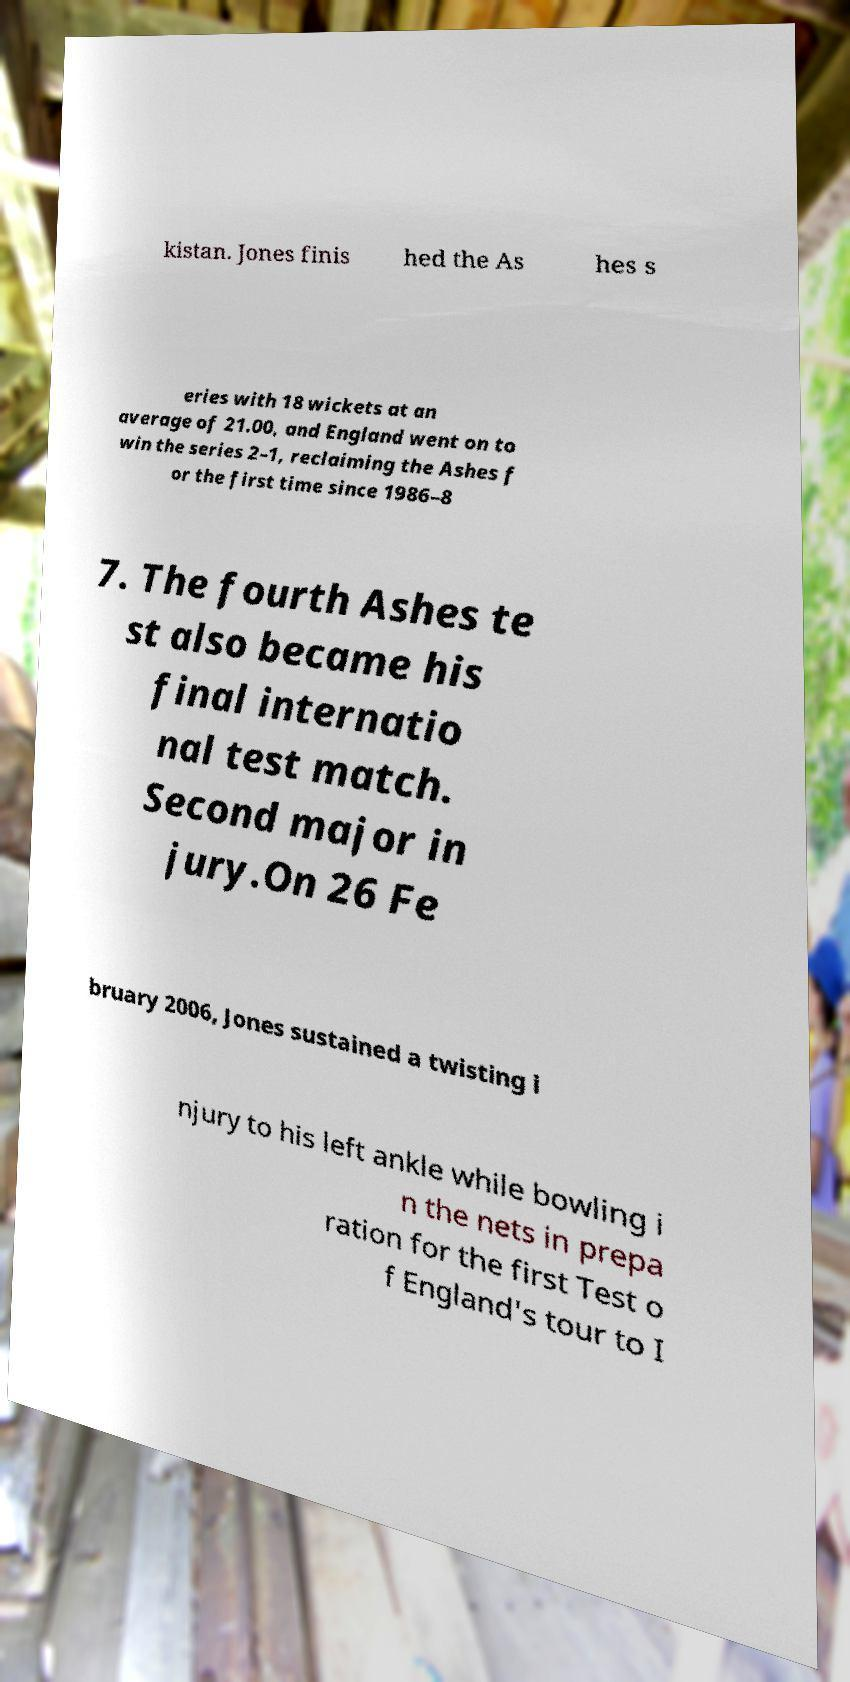What messages or text are displayed in this image? I need them in a readable, typed format. kistan. Jones finis hed the As hes s eries with 18 wickets at an average of 21.00, and England went on to win the series 2–1, reclaiming the Ashes f or the first time since 1986–8 7. The fourth Ashes te st also became his final internatio nal test match. Second major in jury.On 26 Fe bruary 2006, Jones sustained a twisting i njury to his left ankle while bowling i n the nets in prepa ration for the first Test o f England's tour to I 